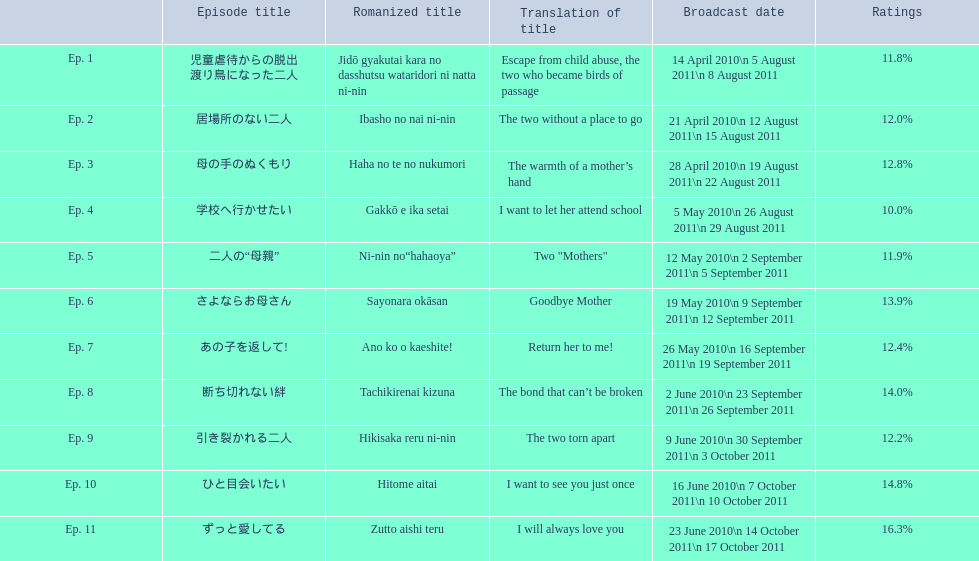What are the rating percentages for each episode? 11.8%, 12.0%, 12.8%, 10.0%, 11.9%, 13.9%, 12.4%, 14.0%, 12.2%, 14.8%, 16.3%. Can you give me this table as a dict? {'header': ['', 'Episode title', 'Romanized title', 'Translation of title', 'Broadcast date', 'Ratings'], 'rows': [['Ep. 1', '児童虐待からの脱出 渡り鳥になった二人', 'Jidō gyakutai kara no dasshutsu wataridori ni natta ni-nin', 'Escape from child abuse, the two who became birds of passage', '14 April 2010\\n 5 August 2011\\n 8 August 2011', '11.8%'], ['Ep. 2', '居場所のない二人', 'Ibasho no nai ni-nin', 'The two without a place to go', '21 April 2010\\n 12 August 2011\\n 15 August 2011', '12.0%'], ['Ep. 3', '母の手のぬくもり', 'Haha no te no nukumori', 'The warmth of a mother’s hand', '28 April 2010\\n 19 August 2011\\n 22 August 2011', '12.8%'], ['Ep. 4', '学校へ行かせたい', 'Gakkō e ika setai', 'I want to let her attend school', '5 May 2010\\n 26 August 2011\\n 29 August 2011', '10.0%'], ['Ep. 5', '二人の“母親”', 'Ni-nin no“hahaoya”', 'Two "Mothers"', '12 May 2010\\n 2 September 2011\\n 5 September 2011', '11.9%'], ['Ep. 6', 'さよならお母さん', 'Sayonara okāsan', 'Goodbye Mother', '19 May 2010\\n 9 September 2011\\n 12 September 2011', '13.9%'], ['Ep. 7', 'あの子を返して!', 'Ano ko o kaeshite!', 'Return her to me!', '26 May 2010\\n 16 September 2011\\n 19 September 2011', '12.4%'], ['Ep. 8', '断ち切れない絆', 'Tachikirenai kizuna', 'The bond that can’t be broken', '2 June 2010\\n 23 September 2011\\n 26 September 2011', '14.0%'], ['Ep. 9', '引き裂かれる二人', 'Hikisaka reru ni-nin', 'The two torn apart', '9 June 2010\\n 30 September 2011\\n 3 October 2011', '12.2%'], ['Ep. 10', 'ひと目会いたい', 'Hitome aitai', 'I want to see you just once', '16 June 2010\\n 7 October 2011\\n 10 October 2011', '14.8%'], ['Ep. 11', 'ずっと愛してる', 'Zutto aishi teru', 'I will always love you', '23 June 2010\\n 14 October 2011\\n 17 October 2011', '16.3%']]} What is the highest rating an episode got? 16.3%. What episode got a rating of 16.3%? ずっと愛してる. 